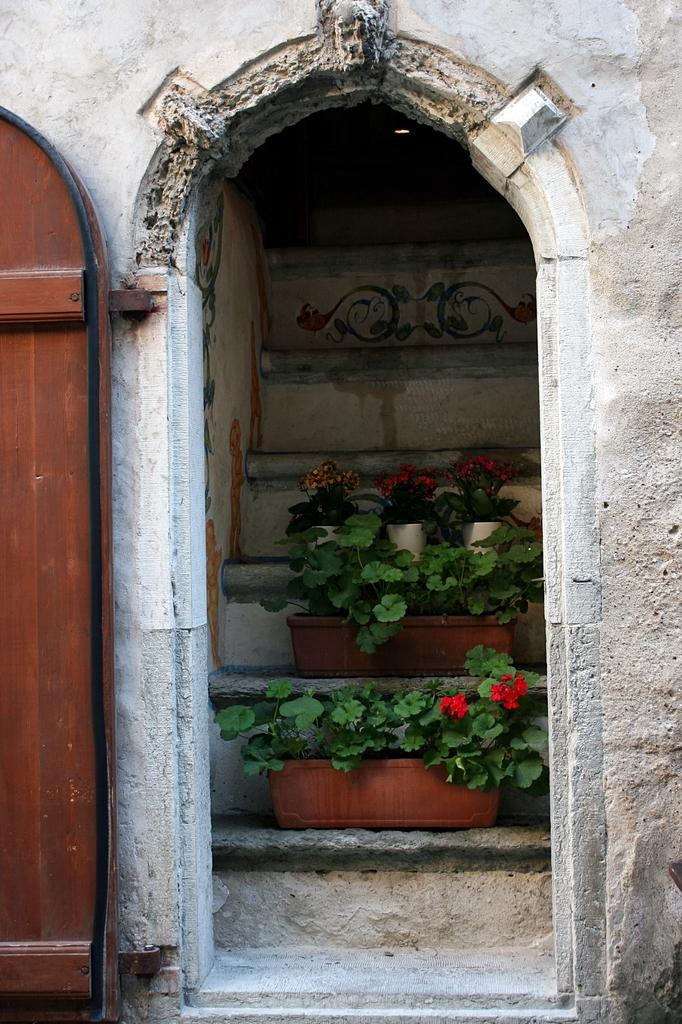What type of structure is visible in the image? There is a building in the image. What can be seen on the staircase in the foreground? There are plants on the staircase in the foreground, and they have flowers on them. Where is the door located in the image? The door is on the left side of the image. Can you see any sails in the image? There are no sails present in the image. What part of the brain is visible in the image? There is no brain visible in the image; it features a building, plants, flowers, and a door. 